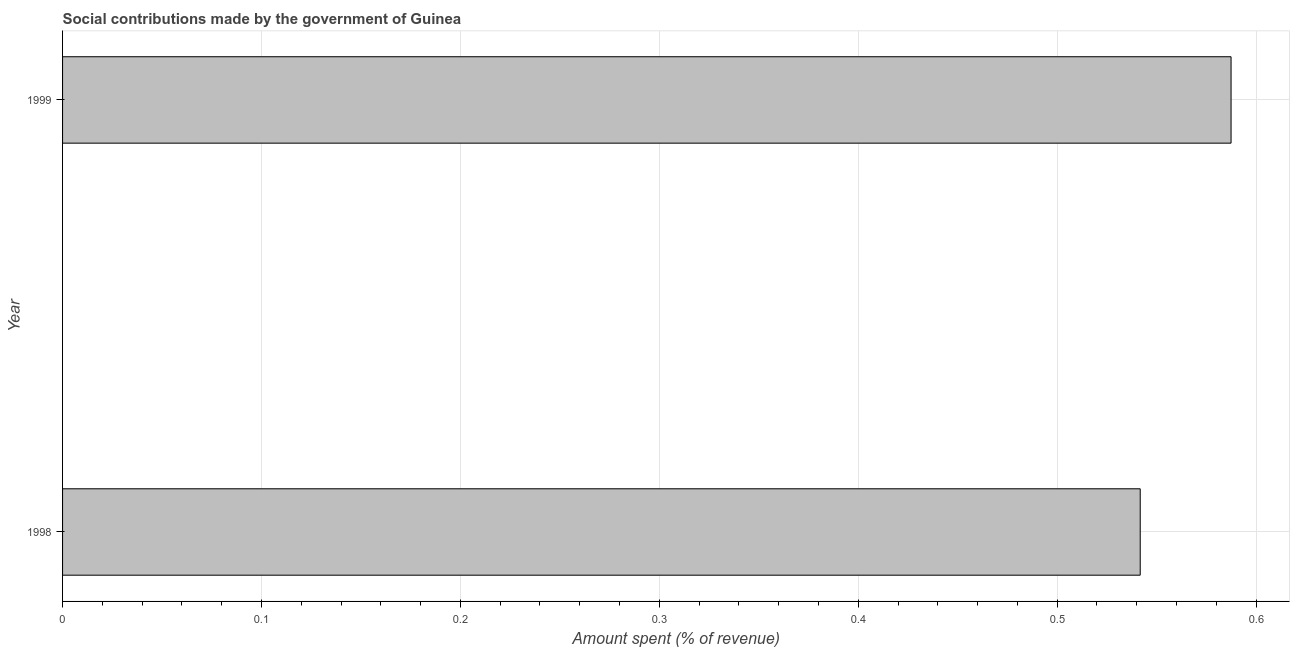What is the title of the graph?
Your response must be concise. Social contributions made by the government of Guinea. What is the label or title of the X-axis?
Keep it short and to the point. Amount spent (% of revenue). What is the label or title of the Y-axis?
Give a very brief answer. Year. What is the amount spent in making social contributions in 1999?
Make the answer very short. 0.59. Across all years, what is the maximum amount spent in making social contributions?
Keep it short and to the point. 0.59. Across all years, what is the minimum amount spent in making social contributions?
Provide a short and direct response. 0.54. In which year was the amount spent in making social contributions maximum?
Your response must be concise. 1999. In which year was the amount spent in making social contributions minimum?
Give a very brief answer. 1998. What is the sum of the amount spent in making social contributions?
Make the answer very short. 1.13. What is the difference between the amount spent in making social contributions in 1998 and 1999?
Ensure brevity in your answer.  -0.05. What is the average amount spent in making social contributions per year?
Make the answer very short. 0.56. What is the median amount spent in making social contributions?
Offer a very short reply. 0.56. Do a majority of the years between 1999 and 1998 (inclusive) have amount spent in making social contributions greater than 0.36 %?
Ensure brevity in your answer.  No. What is the ratio of the amount spent in making social contributions in 1998 to that in 1999?
Make the answer very short. 0.92. In how many years, is the amount spent in making social contributions greater than the average amount spent in making social contributions taken over all years?
Offer a terse response. 1. How many years are there in the graph?
Your answer should be very brief. 2. What is the difference between two consecutive major ticks on the X-axis?
Your response must be concise. 0.1. Are the values on the major ticks of X-axis written in scientific E-notation?
Offer a terse response. No. What is the Amount spent (% of revenue) in 1998?
Your answer should be very brief. 0.54. What is the Amount spent (% of revenue) in 1999?
Your answer should be compact. 0.59. What is the difference between the Amount spent (% of revenue) in 1998 and 1999?
Your answer should be very brief. -0.05. What is the ratio of the Amount spent (% of revenue) in 1998 to that in 1999?
Offer a terse response. 0.92. 